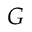Convert formula to latex. <formula><loc_0><loc_0><loc_500><loc_500>G</formula> 